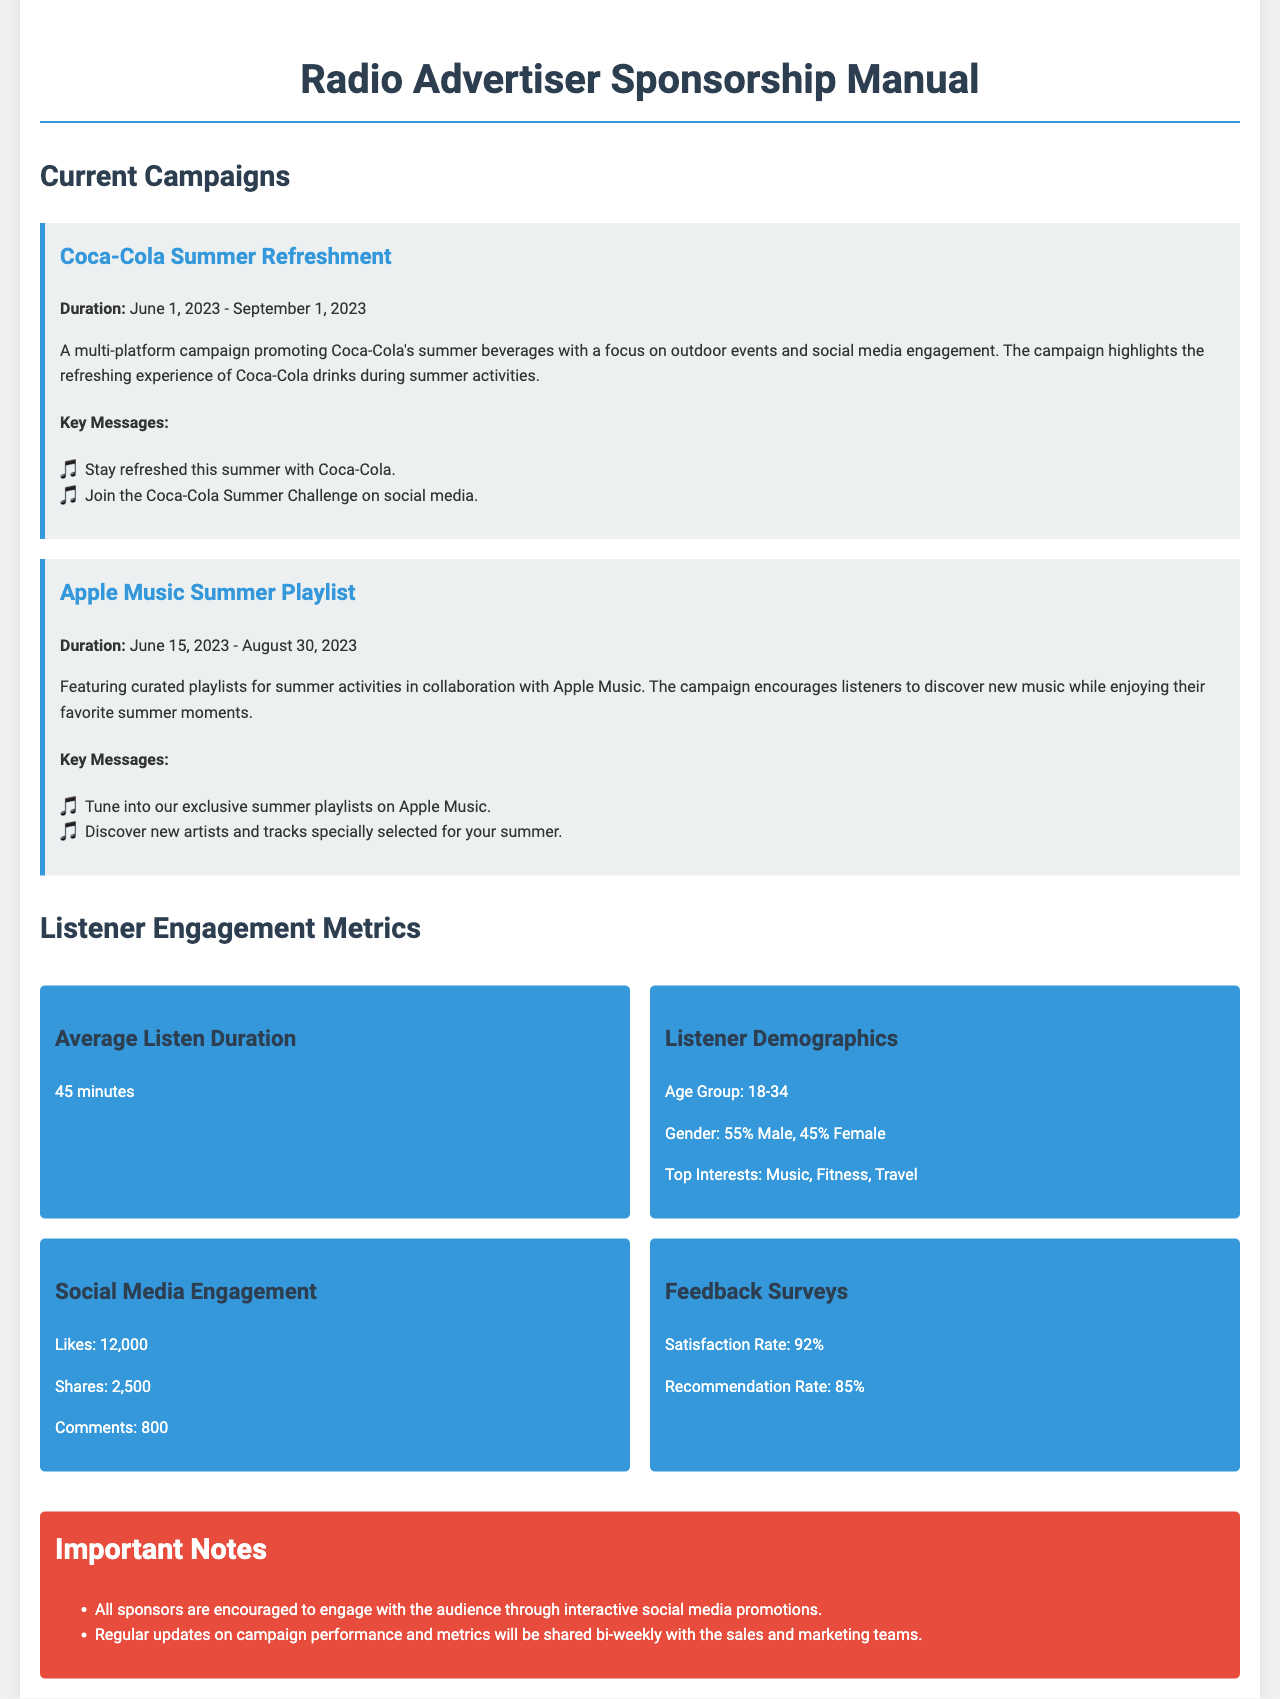What is the duration of the Coca-Cola Summer Refreshment campaign? The duration is specified in the campaign section as June 1, 2023 - September 1, 2023.
Answer: June 1, 2023 - September 1, 2023 How many likes did the social media engagement achieve? The likes are detailed in the Listener Engagement Metrics as 12,000.
Answer: 12,000 What is the average listen duration? The average listen duration is directly mentioned in the metrics section as 45 minutes.
Answer: 45 minutes What is Coca-Cola's key message regarding summer? This is noted in the key messages of the Coca-Cola campaign as "Stay refreshed this summer with Coca-Cola."
Answer: Stay refreshed this summer with Coca-Cola What percentage of listeners are male? The listener demographics specify that 55% of the audience is male.
Answer: 55% Which campaign encourages discovering new music? The Apple Music Summer Playlist campaign focuses on discovering new music for listeners.
Answer: Apple Music Summer Playlist What is the satisfaction rate from feedback surveys? The satisfaction rate is listed in the feedback surveys section as 92%.
Answer: 92% What is recommended to sponsors for audience engagement? The document notes that sponsors are encouraged to engage with the audience through interactive social media promotions.
Answer: Interactive social media promotions What is the age group of the listener demographics? The document specifies the age group as 18-34 in the listener demographics section.
Answer: 18-34 What will be shared bi-weekly with the sales and marketing teams? The document states that regular updates on campaign performance and metrics will be shared bi-weekly.
Answer: Campaign performance and metrics 